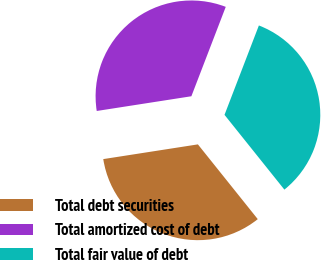Convert chart. <chart><loc_0><loc_0><loc_500><loc_500><pie_chart><fcel>Total debt securities<fcel>Total amortized cost of debt<fcel>Total fair value of debt<nl><fcel>33.29%<fcel>33.3%<fcel>33.41%<nl></chart> 